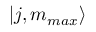<formula> <loc_0><loc_0><loc_500><loc_500>| j , m _ { \max } \rangle</formula> 